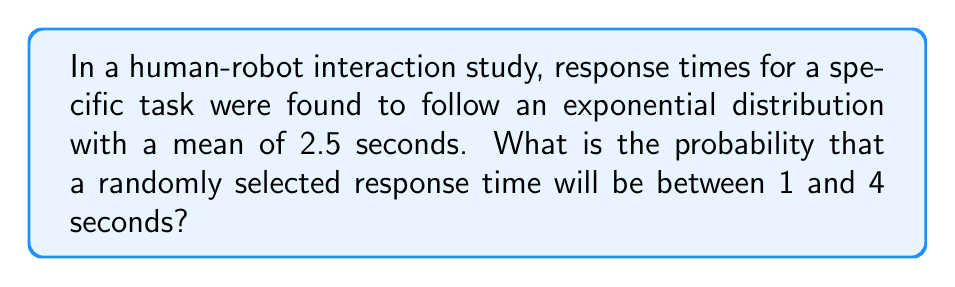Teach me how to tackle this problem. For an undergraduate psychology major, we can approach this problem using the following steps:

1. Recall that the exponential distribution has a probability density function (PDF) of:
   $$f(x) = \lambda e^{-\lambda x}$$
   where $\lambda$ is the rate parameter.

2. Given the mean of 2.5 seconds, we can determine $\lambda$:
   $$\text{Mean} = \frac{1}{\lambda} = 2.5$$
   $$\lambda = \frac{1}{2.5} = 0.4$$

3. To find the probability between 1 and 4 seconds, we need to integrate the PDF from 1 to 4:
   $$P(1 < X < 4) = \int_1^4 0.4e^{-0.4x} dx$$

4. We can solve this integral using the cumulative distribution function (CDF) of the exponential distribution:
   $$F(x) = 1 - e^{-\lambda x}$$

5. Apply the CDF:
   $$P(1 < X < 4) = F(4) - F(1)$$
   $$= (1 - e^{-0.4 \cdot 4}) - (1 - e^{-0.4 \cdot 1})$$
   $$= e^{-0.4} - e^{-1.6}$$

6. Calculate the final result:
   $$= 0.6703 - 0.2019 = 0.4684$$

Therefore, the probability that a randomly selected response time will be between 1 and 4 seconds is approximately 0.4684 or 46.84%.
Answer: 0.4684 